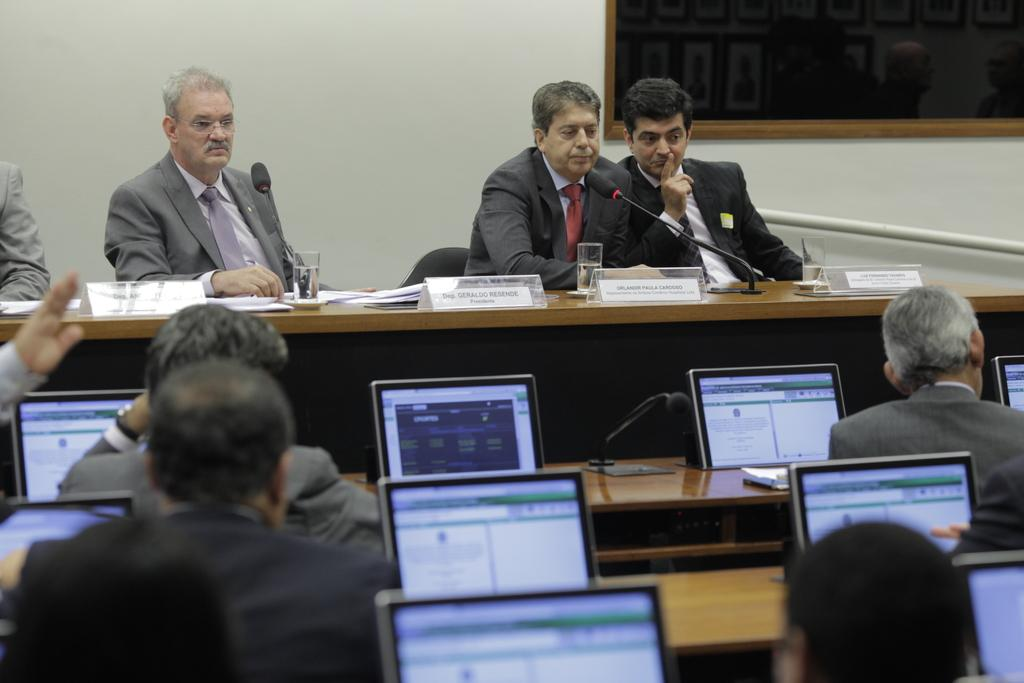What objects can be seen on the table in the image? There are glasses, papers, and text boards on the table in the image. What are the two people holding in the image? The two people are holding microphones. What electronic devices are visible in the image? There are laptops visible in the image. How many people are present in the image? There are people present in the image. What type of rice is being served in the image? There is no rice present in the image. What kind of badge is visible on the people in the image? There are no badges visible on the people in the image. 